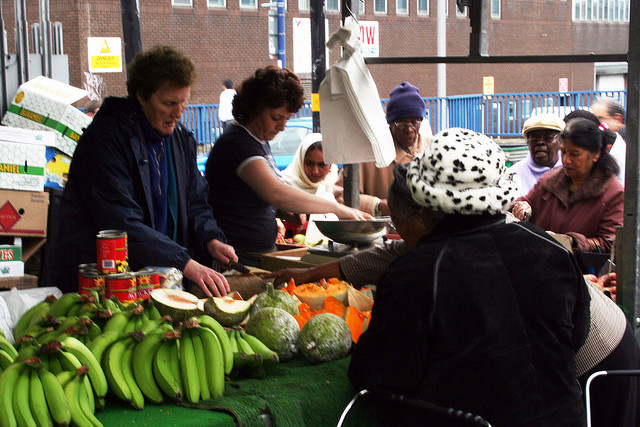Extract all visible text content from this image. IW 